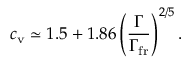<formula> <loc_0><loc_0><loc_500><loc_500>c _ { v } \simeq 1 . 5 + 1 . 8 6 \left ( \frac { \Gamma } { \Gamma _ { f r } } \right ) ^ { 2 / 5 } .</formula> 